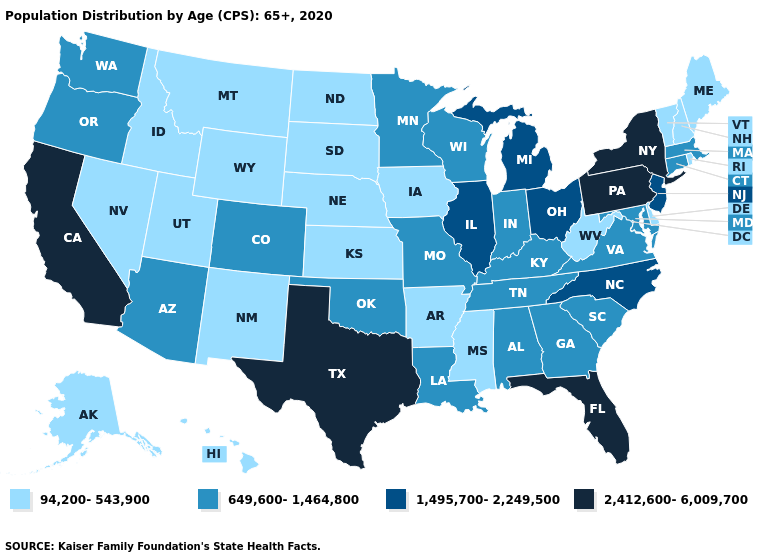What is the value of New York?
Quick response, please. 2,412,600-6,009,700. Name the states that have a value in the range 94,200-543,900?
Quick response, please. Alaska, Arkansas, Delaware, Hawaii, Idaho, Iowa, Kansas, Maine, Mississippi, Montana, Nebraska, Nevada, New Hampshire, New Mexico, North Dakota, Rhode Island, South Dakota, Utah, Vermont, West Virginia, Wyoming. What is the highest value in the USA?
Write a very short answer. 2,412,600-6,009,700. Name the states that have a value in the range 1,495,700-2,249,500?
Quick response, please. Illinois, Michigan, New Jersey, North Carolina, Ohio. Does Maryland have the highest value in the South?
Write a very short answer. No. Does Oregon have a higher value than Wyoming?
Keep it brief. Yes. Name the states that have a value in the range 94,200-543,900?
Short answer required. Alaska, Arkansas, Delaware, Hawaii, Idaho, Iowa, Kansas, Maine, Mississippi, Montana, Nebraska, Nevada, New Hampshire, New Mexico, North Dakota, Rhode Island, South Dakota, Utah, Vermont, West Virginia, Wyoming. What is the value of Arizona?
Short answer required. 649,600-1,464,800. Name the states that have a value in the range 1,495,700-2,249,500?
Write a very short answer. Illinois, Michigan, New Jersey, North Carolina, Ohio. Among the states that border Nebraska , which have the highest value?
Give a very brief answer. Colorado, Missouri. Does Indiana have the highest value in the MidWest?
Quick response, please. No. What is the value of Oregon?
Concise answer only. 649,600-1,464,800. What is the value of Vermont?
Give a very brief answer. 94,200-543,900. Is the legend a continuous bar?
Answer briefly. No. Does Wyoming have the lowest value in the USA?
Be succinct. Yes. 